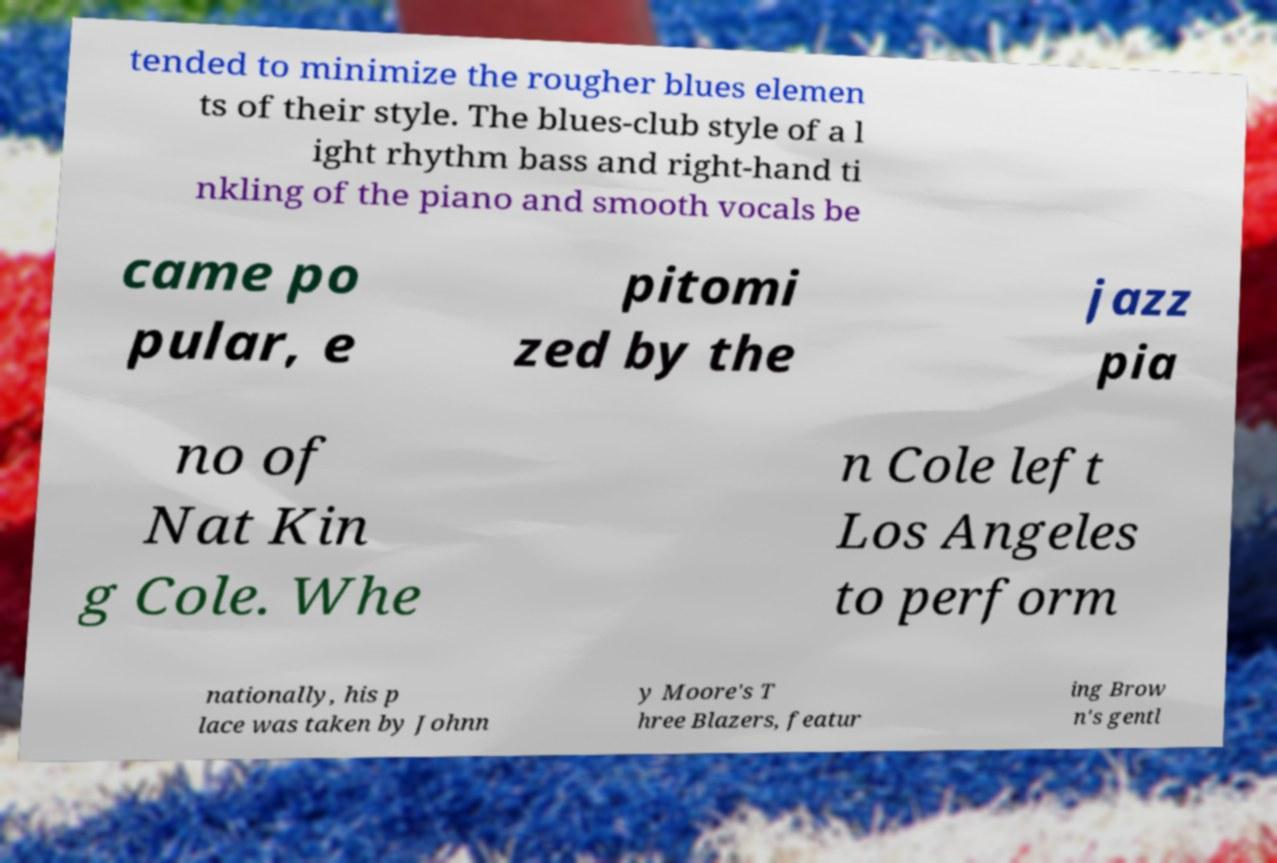There's text embedded in this image that I need extracted. Can you transcribe it verbatim? tended to minimize the rougher blues elemen ts of their style. The blues-club style of a l ight rhythm bass and right-hand ti nkling of the piano and smooth vocals be came po pular, e pitomi zed by the jazz pia no of Nat Kin g Cole. Whe n Cole left Los Angeles to perform nationally, his p lace was taken by Johnn y Moore's T hree Blazers, featur ing Brow n's gentl 